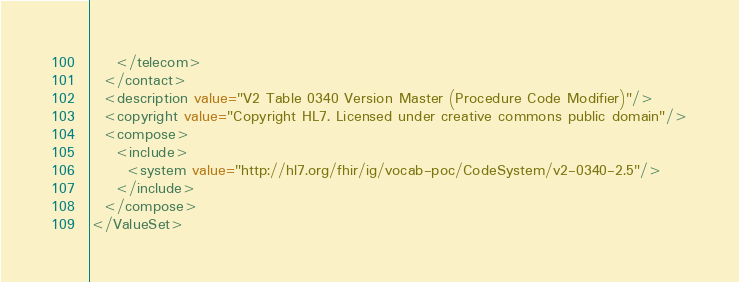<code> <loc_0><loc_0><loc_500><loc_500><_XML_>    </telecom>
  </contact>
  <description value="V2 Table 0340 Version Master (Procedure Code Modifier)"/>
  <copyright value="Copyright HL7. Licensed under creative commons public domain"/>
  <compose>
    <include>
      <system value="http://hl7.org/fhir/ig/vocab-poc/CodeSystem/v2-0340-2.5"/>
    </include>
  </compose>
</ValueSet></code> 